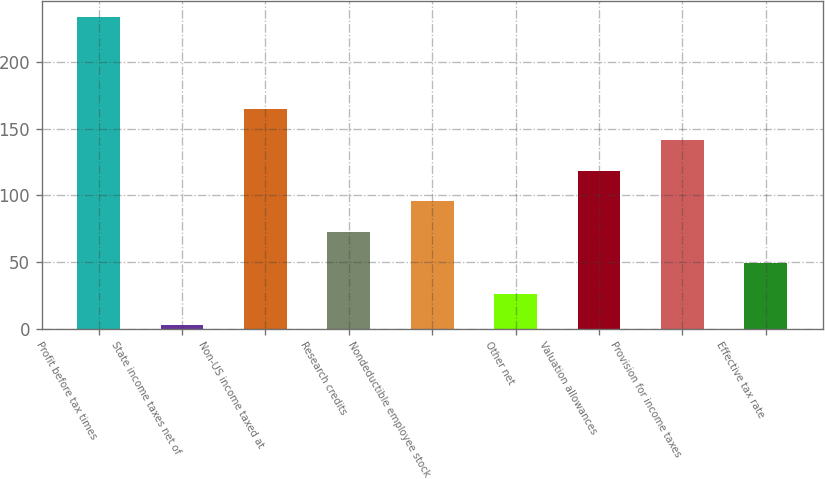Convert chart. <chart><loc_0><loc_0><loc_500><loc_500><bar_chart><fcel>Profit before tax times<fcel>State income taxes net of<fcel>Non-US income taxed at<fcel>Research credits<fcel>Nondeductible employee stock<fcel>Other net<fcel>Valuation allowances<fcel>Provision for income taxes<fcel>Effective tax rate<nl><fcel>234<fcel>3<fcel>164.7<fcel>72.3<fcel>95.4<fcel>26.1<fcel>118.5<fcel>141.6<fcel>49.2<nl></chart> 